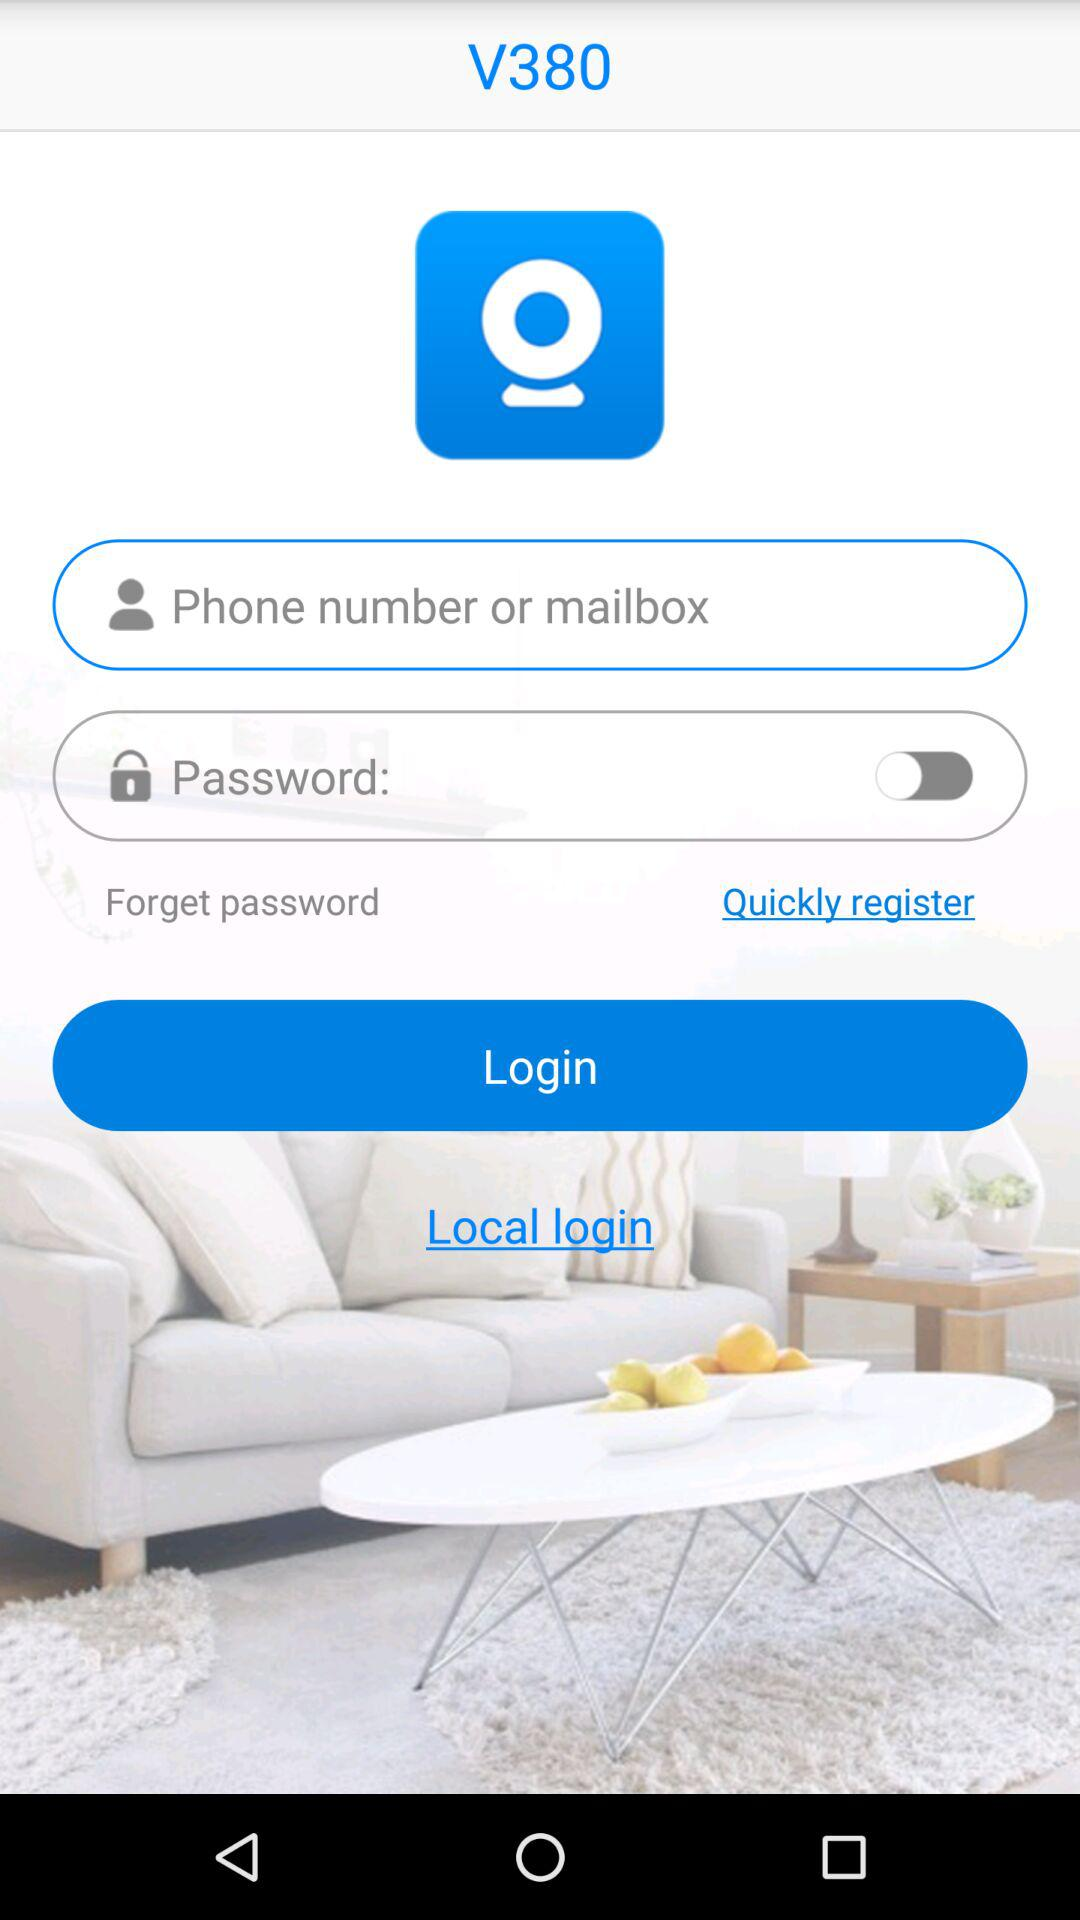What are the requirements to log in? The requirements to log in are "Phone number or mailbox" and "Password". 